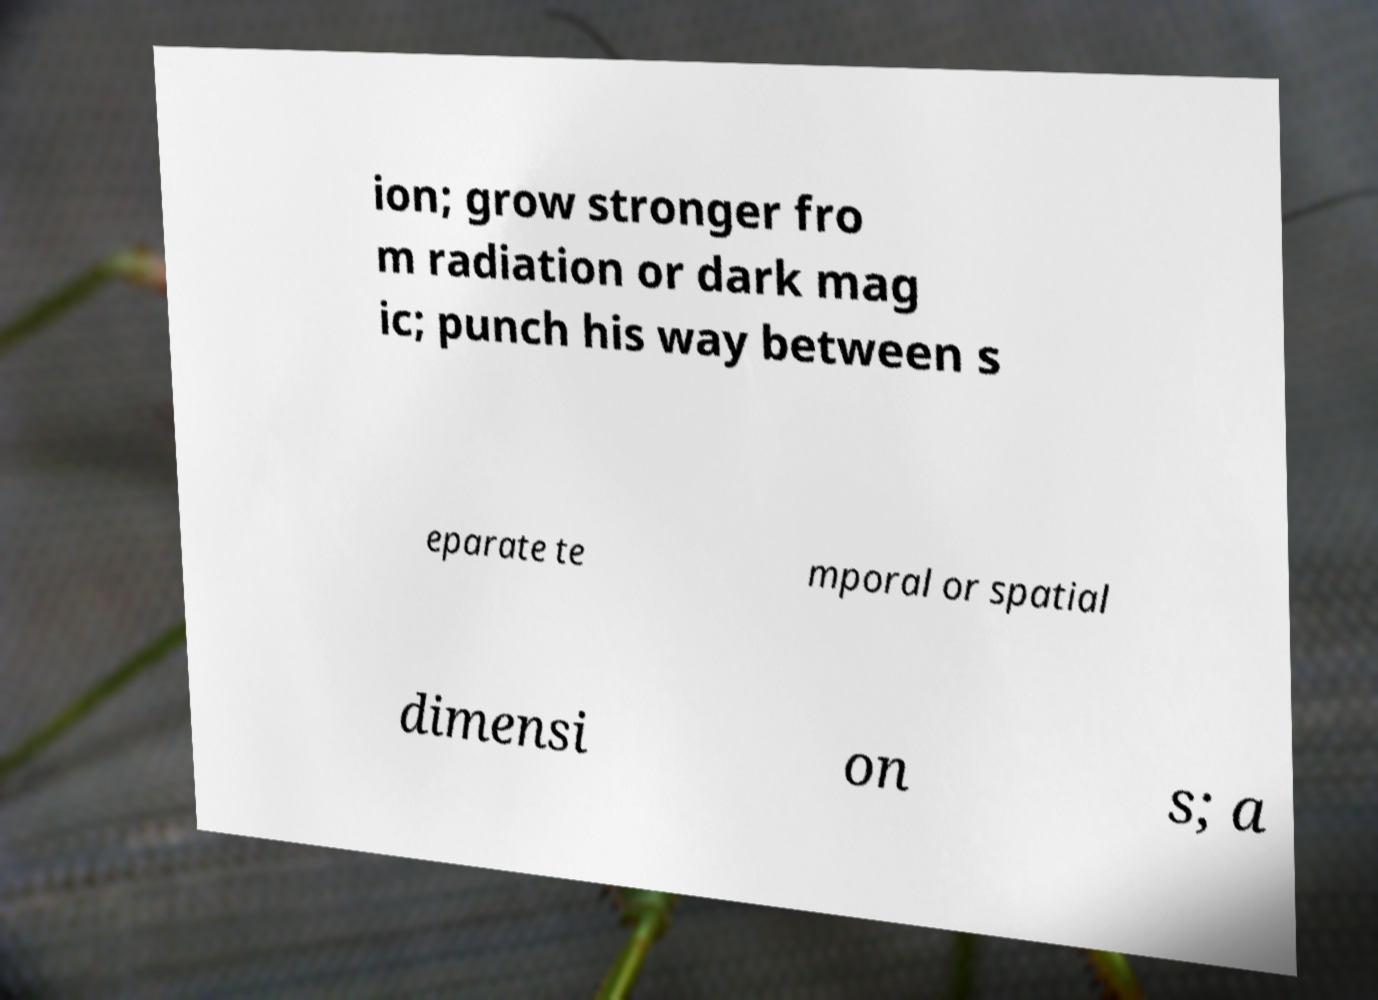Can you read and provide the text displayed in the image?This photo seems to have some interesting text. Can you extract and type it out for me? ion; grow stronger fro m radiation or dark mag ic; punch his way between s eparate te mporal or spatial dimensi on s; a 